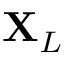<formula> <loc_0><loc_0><loc_500><loc_500>X _ { L }</formula> 